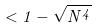<formula> <loc_0><loc_0><loc_500><loc_500>< 1 - \sqrt { N ^ { 4 } }</formula> 